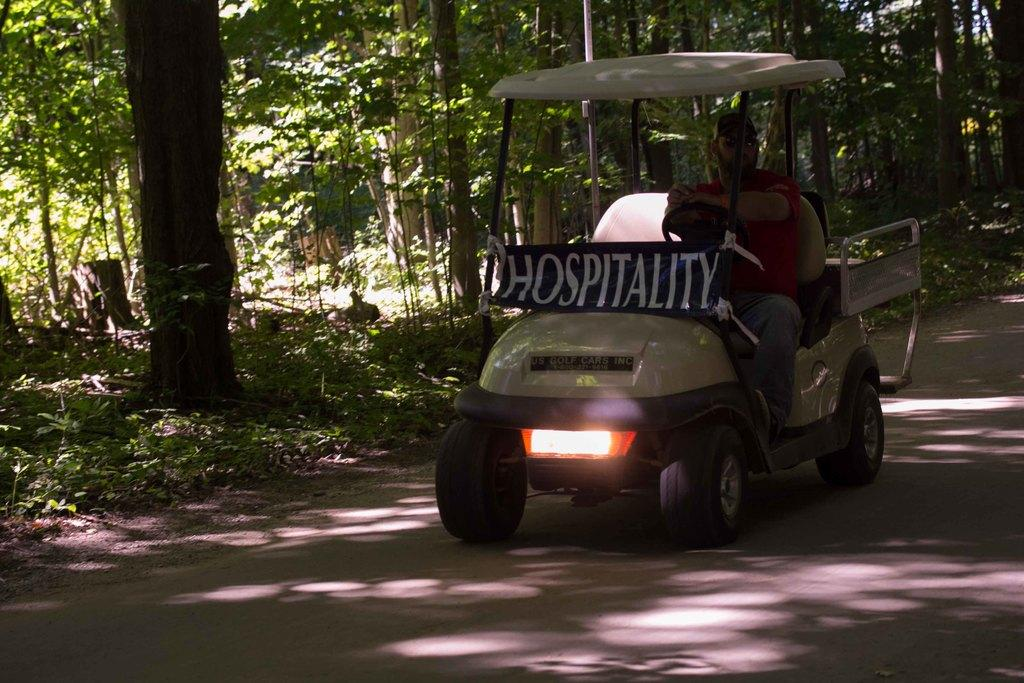What is the main subject in the foreground of the picture? There is a vehicle in the foreground of the picture. Who is operating the vehicle? A person is riding the vehicle. What can be seen in the center of the picture? There are trees, plants, and other objects in the center of the picture. What type of reward is being given to the person riding the vehicle in the image? There is no reward being given to the person riding the vehicle in the image. What kind of net is visible in the image? There is no net present in the image. 